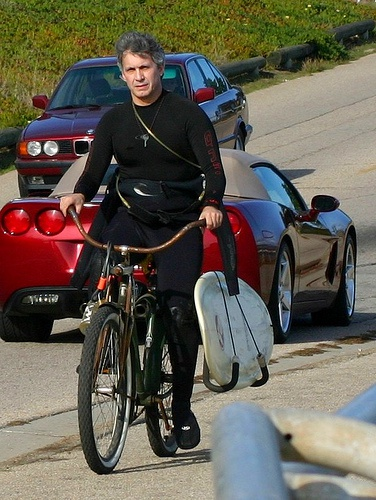Describe the objects in this image and their specific colors. I can see people in olive, black, gray, tan, and maroon tones, car in olive, black, maroon, and gray tones, bicycle in olive, black, gray, and darkgray tones, car in olive, black, gray, navy, and blue tones, and surfboard in olive, darkgray, and gray tones in this image. 